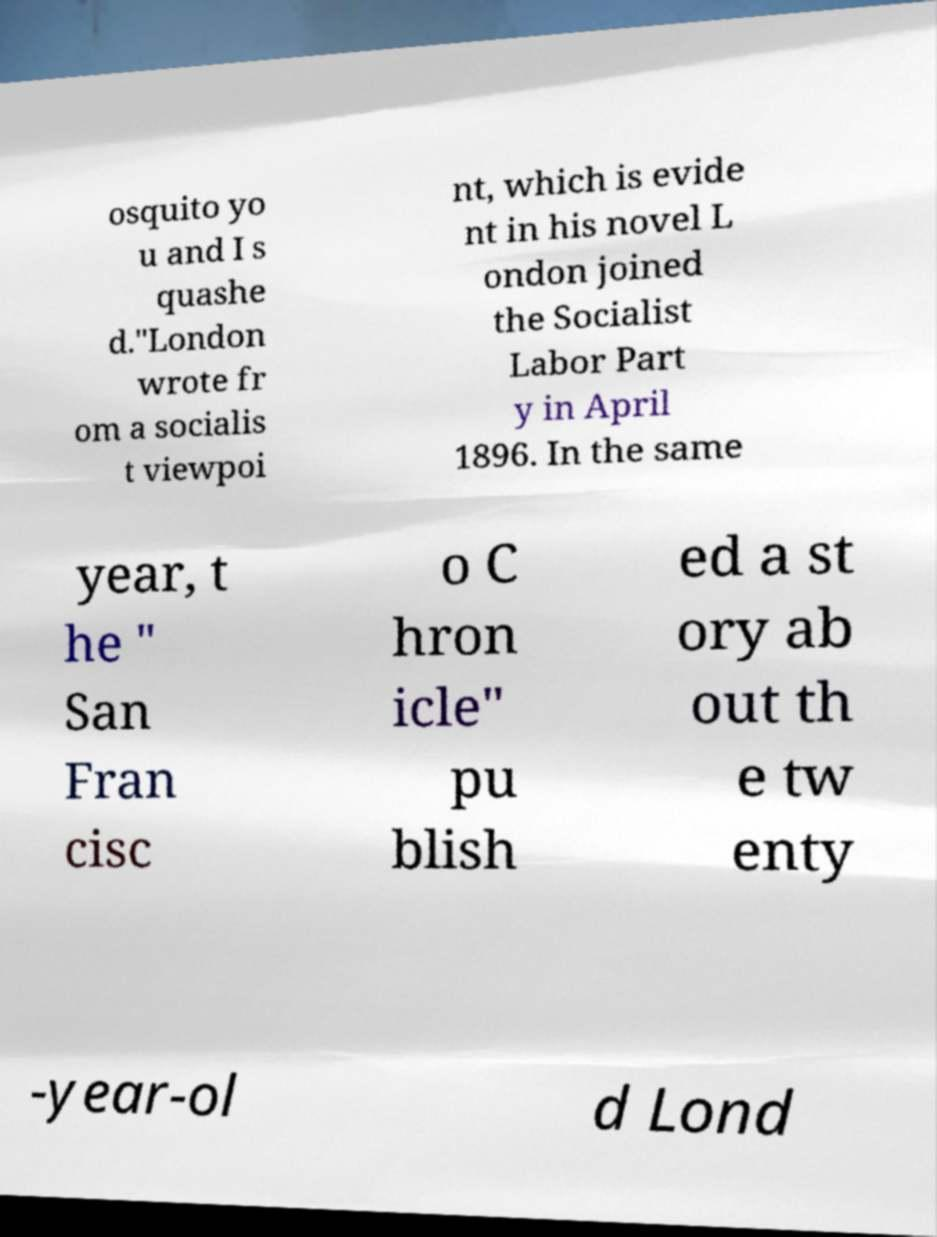Could you assist in decoding the text presented in this image and type it out clearly? osquito yo u and I s quashe d."London wrote fr om a socialis t viewpoi nt, which is evide nt in his novel L ondon joined the Socialist Labor Part y in April 1896. In the same year, t he " San Fran cisc o C hron icle" pu blish ed a st ory ab out th e tw enty -year-ol d Lond 